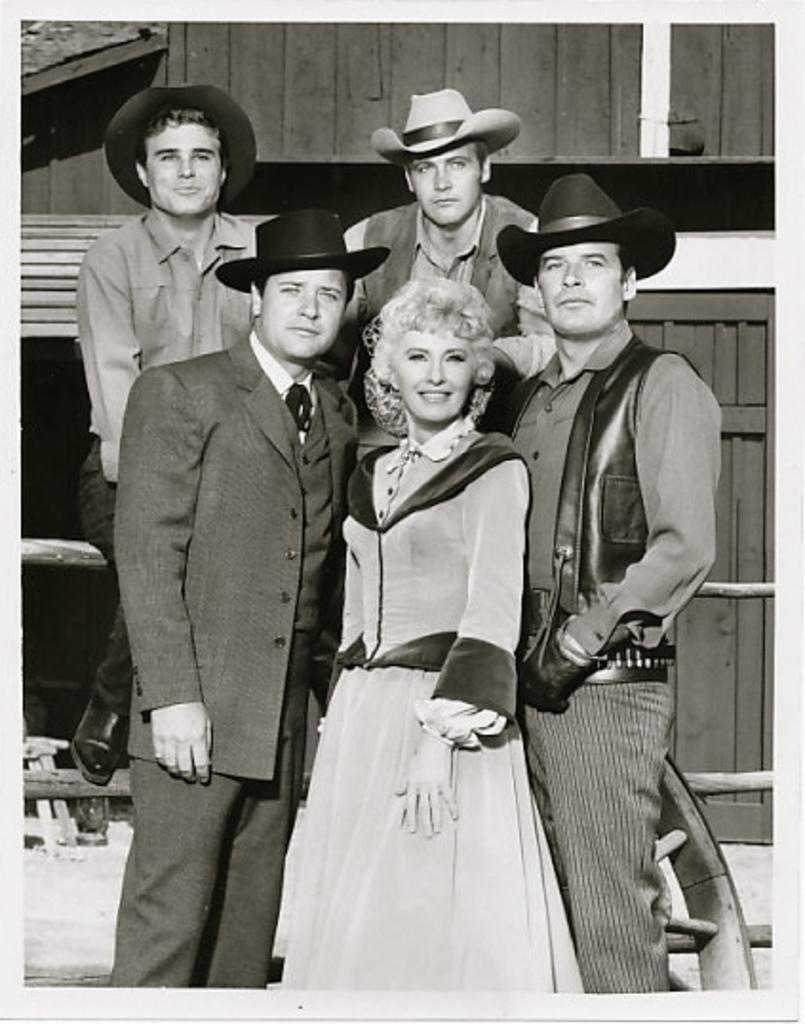Could you give a brief overview of what you see in this image? I see this is a black and white image and I see 4 men and a woman and I see that these 4 men are wearing hats and I see that this woman and this man are smiling. In the background I see the wooden things. 